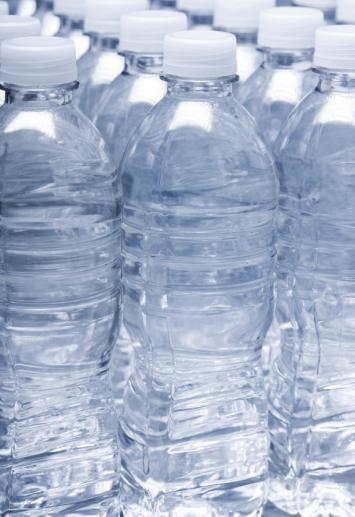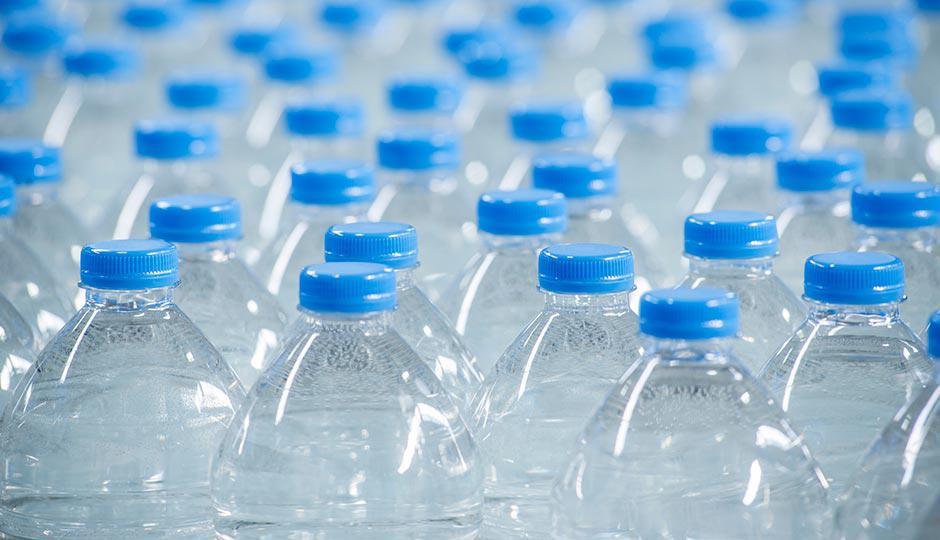The first image is the image on the left, the second image is the image on the right. Assess this claim about the two images: "Bottles with blue caps are on a blue grated surface.". Correct or not? Answer yes or no. No. The first image is the image on the left, the second image is the image on the right. Assess this claim about the two images: "an image shows individual, unwrapped bottles with white lids.". Correct or not? Answer yes or no. Yes. 